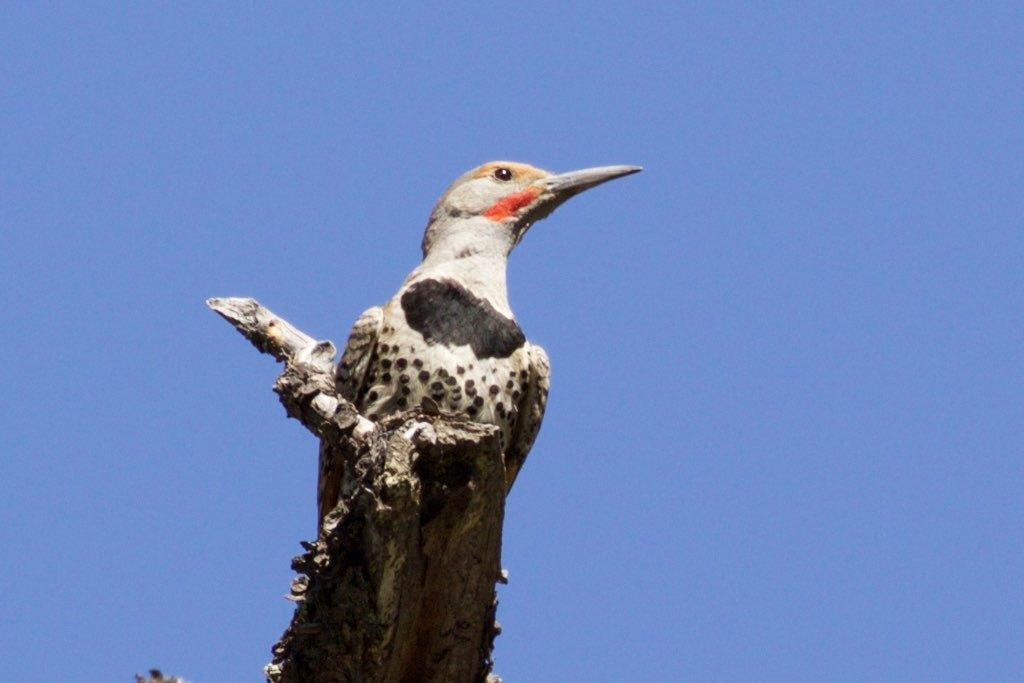What type of animal can be seen in the image? There is a bird on a wood in the image. What is the bird perched on? The bird is perched on a wood. What can be seen in the background of the image? There is sky visible in the background of the image. What type of underwear is the bird wearing in the image? There is no underwear present in the image, as birds do not wear clothing. 